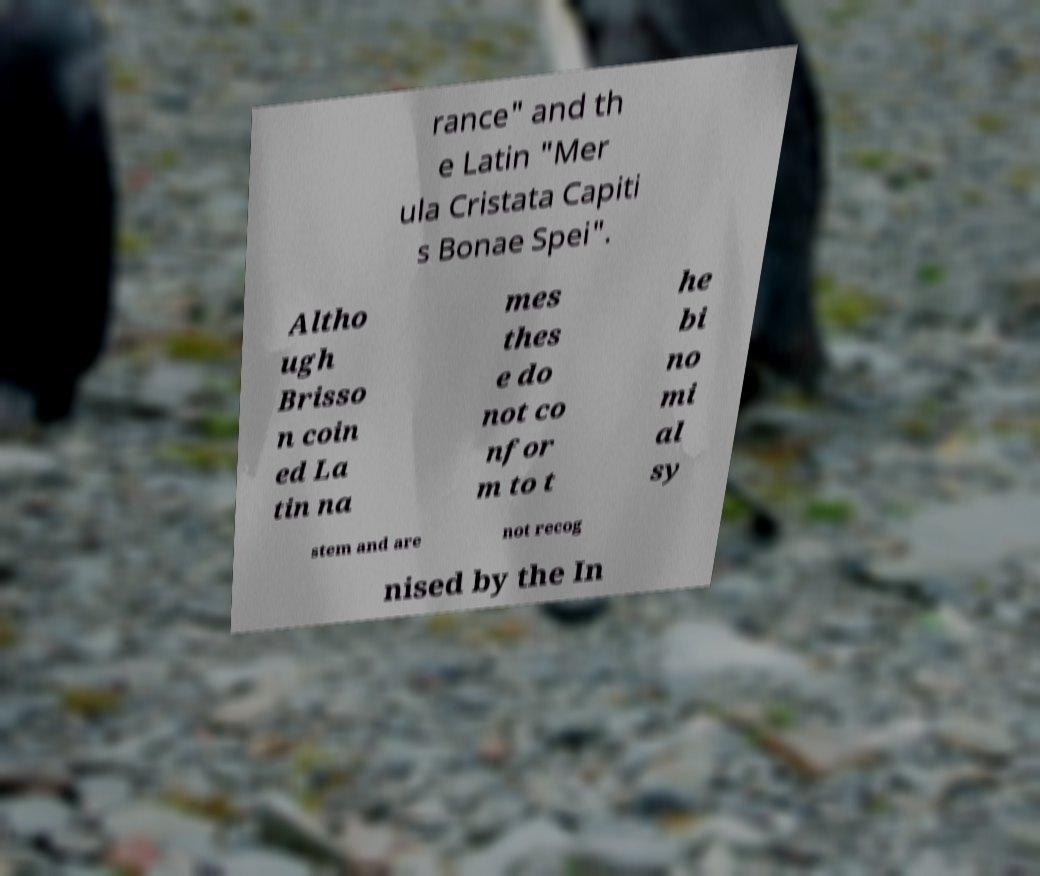Please identify and transcribe the text found in this image. rance" and th e Latin "Mer ula Cristata Capiti s Bonae Spei". Altho ugh Brisso n coin ed La tin na mes thes e do not co nfor m to t he bi no mi al sy stem and are not recog nised by the In 